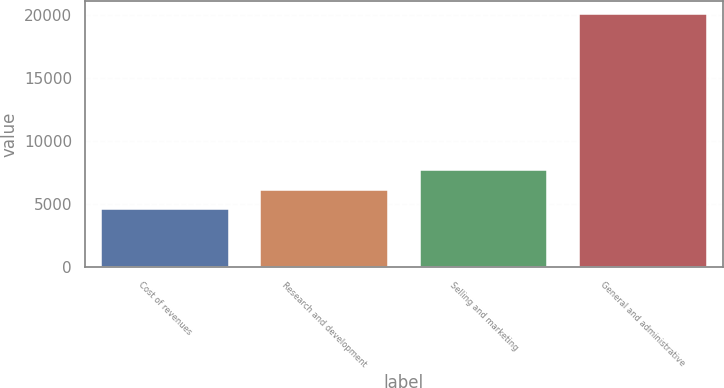Convert chart. <chart><loc_0><loc_0><loc_500><loc_500><bar_chart><fcel>Cost of revenues<fcel>Research and development<fcel>Selling and marketing<fcel>General and administrative<nl><fcel>4602<fcel>6148.2<fcel>7694.4<fcel>20064<nl></chart> 